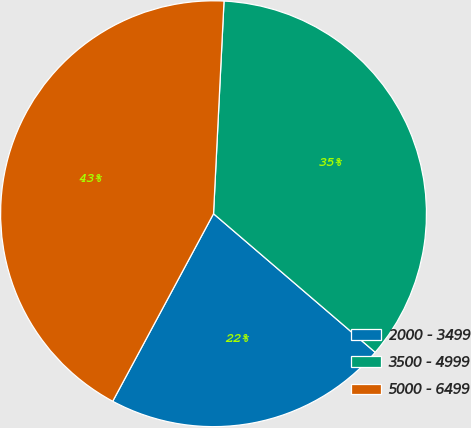<chart> <loc_0><loc_0><loc_500><loc_500><pie_chart><fcel>2000 - 3499<fcel>3500 - 4999<fcel>5000 - 6499<nl><fcel>21.57%<fcel>35.49%<fcel>42.93%<nl></chart> 